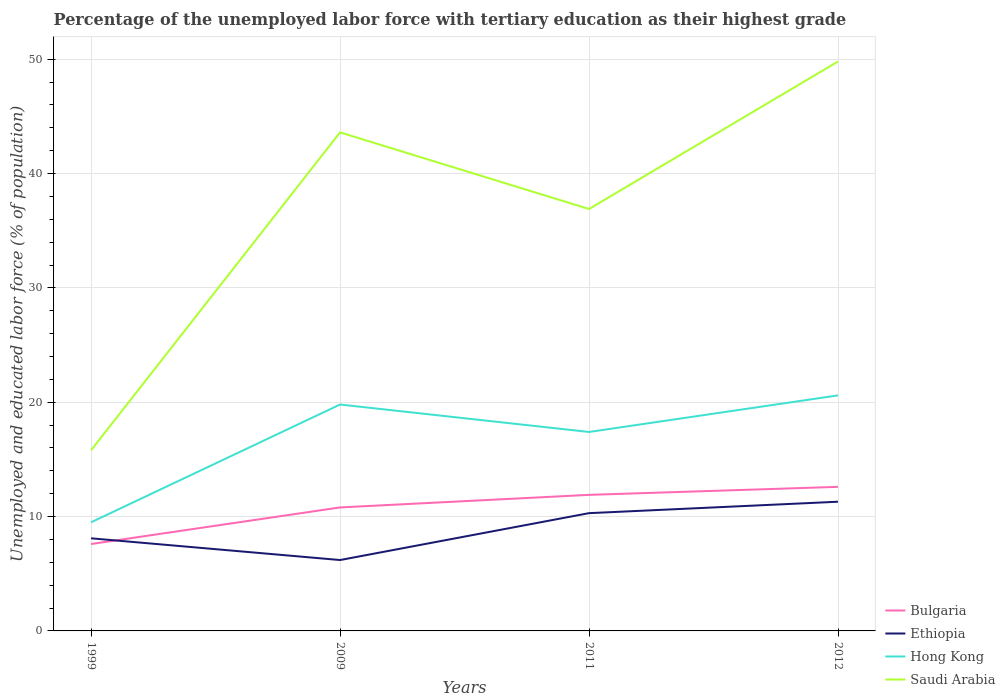How many different coloured lines are there?
Your answer should be very brief. 4. Does the line corresponding to Ethiopia intersect with the line corresponding to Bulgaria?
Offer a very short reply. Yes. Is the number of lines equal to the number of legend labels?
Make the answer very short. Yes. Across all years, what is the maximum percentage of the unemployed labor force with tertiary education in Hong Kong?
Provide a succinct answer. 9.5. What is the total percentage of the unemployed labor force with tertiary education in Ethiopia in the graph?
Your answer should be very brief. -4.1. What is the difference between the highest and the second highest percentage of the unemployed labor force with tertiary education in Hong Kong?
Give a very brief answer. 11.1. Are the values on the major ticks of Y-axis written in scientific E-notation?
Give a very brief answer. No. How many legend labels are there?
Offer a very short reply. 4. What is the title of the graph?
Provide a short and direct response. Percentage of the unemployed labor force with tertiary education as their highest grade. Does "St. Vincent and the Grenadines" appear as one of the legend labels in the graph?
Provide a succinct answer. No. What is the label or title of the Y-axis?
Keep it short and to the point. Unemployed and educated labor force (% of population). What is the Unemployed and educated labor force (% of population) in Bulgaria in 1999?
Offer a terse response. 7.6. What is the Unemployed and educated labor force (% of population) in Ethiopia in 1999?
Your answer should be compact. 8.1. What is the Unemployed and educated labor force (% of population) of Saudi Arabia in 1999?
Your answer should be compact. 15.8. What is the Unemployed and educated labor force (% of population) in Bulgaria in 2009?
Give a very brief answer. 10.8. What is the Unemployed and educated labor force (% of population) of Ethiopia in 2009?
Provide a short and direct response. 6.2. What is the Unemployed and educated labor force (% of population) in Hong Kong in 2009?
Your response must be concise. 19.8. What is the Unemployed and educated labor force (% of population) in Saudi Arabia in 2009?
Keep it short and to the point. 43.6. What is the Unemployed and educated labor force (% of population) of Bulgaria in 2011?
Your response must be concise. 11.9. What is the Unemployed and educated labor force (% of population) in Ethiopia in 2011?
Your response must be concise. 10.3. What is the Unemployed and educated labor force (% of population) of Hong Kong in 2011?
Your answer should be very brief. 17.4. What is the Unemployed and educated labor force (% of population) of Saudi Arabia in 2011?
Keep it short and to the point. 36.9. What is the Unemployed and educated labor force (% of population) of Bulgaria in 2012?
Provide a short and direct response. 12.6. What is the Unemployed and educated labor force (% of population) in Ethiopia in 2012?
Your answer should be compact. 11.3. What is the Unemployed and educated labor force (% of population) of Hong Kong in 2012?
Give a very brief answer. 20.6. What is the Unemployed and educated labor force (% of population) of Saudi Arabia in 2012?
Give a very brief answer. 49.8. Across all years, what is the maximum Unemployed and educated labor force (% of population) in Bulgaria?
Offer a very short reply. 12.6. Across all years, what is the maximum Unemployed and educated labor force (% of population) of Ethiopia?
Provide a short and direct response. 11.3. Across all years, what is the maximum Unemployed and educated labor force (% of population) of Hong Kong?
Your answer should be compact. 20.6. Across all years, what is the maximum Unemployed and educated labor force (% of population) of Saudi Arabia?
Make the answer very short. 49.8. Across all years, what is the minimum Unemployed and educated labor force (% of population) in Bulgaria?
Provide a short and direct response. 7.6. Across all years, what is the minimum Unemployed and educated labor force (% of population) of Ethiopia?
Give a very brief answer. 6.2. Across all years, what is the minimum Unemployed and educated labor force (% of population) of Hong Kong?
Ensure brevity in your answer.  9.5. Across all years, what is the minimum Unemployed and educated labor force (% of population) in Saudi Arabia?
Your response must be concise. 15.8. What is the total Unemployed and educated labor force (% of population) in Bulgaria in the graph?
Your answer should be compact. 42.9. What is the total Unemployed and educated labor force (% of population) in Ethiopia in the graph?
Your response must be concise. 35.9. What is the total Unemployed and educated labor force (% of population) of Hong Kong in the graph?
Your answer should be compact. 67.3. What is the total Unemployed and educated labor force (% of population) in Saudi Arabia in the graph?
Provide a succinct answer. 146.1. What is the difference between the Unemployed and educated labor force (% of population) of Bulgaria in 1999 and that in 2009?
Provide a short and direct response. -3.2. What is the difference between the Unemployed and educated labor force (% of population) in Saudi Arabia in 1999 and that in 2009?
Your answer should be compact. -27.8. What is the difference between the Unemployed and educated labor force (% of population) in Bulgaria in 1999 and that in 2011?
Provide a short and direct response. -4.3. What is the difference between the Unemployed and educated labor force (% of population) in Ethiopia in 1999 and that in 2011?
Offer a terse response. -2.2. What is the difference between the Unemployed and educated labor force (% of population) of Saudi Arabia in 1999 and that in 2011?
Give a very brief answer. -21.1. What is the difference between the Unemployed and educated labor force (% of population) in Ethiopia in 1999 and that in 2012?
Keep it short and to the point. -3.2. What is the difference between the Unemployed and educated labor force (% of population) in Saudi Arabia in 1999 and that in 2012?
Provide a short and direct response. -34. What is the difference between the Unemployed and educated labor force (% of population) in Ethiopia in 2009 and that in 2011?
Your answer should be very brief. -4.1. What is the difference between the Unemployed and educated labor force (% of population) in Hong Kong in 2009 and that in 2011?
Your response must be concise. 2.4. What is the difference between the Unemployed and educated labor force (% of population) in Bulgaria in 2009 and that in 2012?
Provide a short and direct response. -1.8. What is the difference between the Unemployed and educated labor force (% of population) of Bulgaria in 2011 and that in 2012?
Give a very brief answer. -0.7. What is the difference between the Unemployed and educated labor force (% of population) in Bulgaria in 1999 and the Unemployed and educated labor force (% of population) in Ethiopia in 2009?
Offer a terse response. 1.4. What is the difference between the Unemployed and educated labor force (% of population) in Bulgaria in 1999 and the Unemployed and educated labor force (% of population) in Hong Kong in 2009?
Ensure brevity in your answer.  -12.2. What is the difference between the Unemployed and educated labor force (% of population) of Bulgaria in 1999 and the Unemployed and educated labor force (% of population) of Saudi Arabia in 2009?
Ensure brevity in your answer.  -36. What is the difference between the Unemployed and educated labor force (% of population) of Ethiopia in 1999 and the Unemployed and educated labor force (% of population) of Hong Kong in 2009?
Your answer should be very brief. -11.7. What is the difference between the Unemployed and educated labor force (% of population) of Ethiopia in 1999 and the Unemployed and educated labor force (% of population) of Saudi Arabia in 2009?
Provide a succinct answer. -35.5. What is the difference between the Unemployed and educated labor force (% of population) of Hong Kong in 1999 and the Unemployed and educated labor force (% of population) of Saudi Arabia in 2009?
Offer a very short reply. -34.1. What is the difference between the Unemployed and educated labor force (% of population) of Bulgaria in 1999 and the Unemployed and educated labor force (% of population) of Hong Kong in 2011?
Make the answer very short. -9.8. What is the difference between the Unemployed and educated labor force (% of population) in Bulgaria in 1999 and the Unemployed and educated labor force (% of population) in Saudi Arabia in 2011?
Make the answer very short. -29.3. What is the difference between the Unemployed and educated labor force (% of population) in Ethiopia in 1999 and the Unemployed and educated labor force (% of population) in Saudi Arabia in 2011?
Provide a succinct answer. -28.8. What is the difference between the Unemployed and educated labor force (% of population) of Hong Kong in 1999 and the Unemployed and educated labor force (% of population) of Saudi Arabia in 2011?
Offer a terse response. -27.4. What is the difference between the Unemployed and educated labor force (% of population) of Bulgaria in 1999 and the Unemployed and educated labor force (% of population) of Ethiopia in 2012?
Provide a short and direct response. -3.7. What is the difference between the Unemployed and educated labor force (% of population) of Bulgaria in 1999 and the Unemployed and educated labor force (% of population) of Saudi Arabia in 2012?
Your response must be concise. -42.2. What is the difference between the Unemployed and educated labor force (% of population) in Ethiopia in 1999 and the Unemployed and educated labor force (% of population) in Saudi Arabia in 2012?
Provide a short and direct response. -41.7. What is the difference between the Unemployed and educated labor force (% of population) of Hong Kong in 1999 and the Unemployed and educated labor force (% of population) of Saudi Arabia in 2012?
Your answer should be compact. -40.3. What is the difference between the Unemployed and educated labor force (% of population) of Bulgaria in 2009 and the Unemployed and educated labor force (% of population) of Ethiopia in 2011?
Your answer should be very brief. 0.5. What is the difference between the Unemployed and educated labor force (% of population) of Bulgaria in 2009 and the Unemployed and educated labor force (% of population) of Hong Kong in 2011?
Make the answer very short. -6.6. What is the difference between the Unemployed and educated labor force (% of population) of Bulgaria in 2009 and the Unemployed and educated labor force (% of population) of Saudi Arabia in 2011?
Offer a very short reply. -26.1. What is the difference between the Unemployed and educated labor force (% of population) in Ethiopia in 2009 and the Unemployed and educated labor force (% of population) in Hong Kong in 2011?
Keep it short and to the point. -11.2. What is the difference between the Unemployed and educated labor force (% of population) in Ethiopia in 2009 and the Unemployed and educated labor force (% of population) in Saudi Arabia in 2011?
Your answer should be compact. -30.7. What is the difference between the Unemployed and educated labor force (% of population) of Hong Kong in 2009 and the Unemployed and educated labor force (% of population) of Saudi Arabia in 2011?
Provide a succinct answer. -17.1. What is the difference between the Unemployed and educated labor force (% of population) of Bulgaria in 2009 and the Unemployed and educated labor force (% of population) of Ethiopia in 2012?
Your answer should be very brief. -0.5. What is the difference between the Unemployed and educated labor force (% of population) in Bulgaria in 2009 and the Unemployed and educated labor force (% of population) in Hong Kong in 2012?
Your response must be concise. -9.8. What is the difference between the Unemployed and educated labor force (% of population) of Bulgaria in 2009 and the Unemployed and educated labor force (% of population) of Saudi Arabia in 2012?
Offer a very short reply. -39. What is the difference between the Unemployed and educated labor force (% of population) of Ethiopia in 2009 and the Unemployed and educated labor force (% of population) of Hong Kong in 2012?
Your answer should be compact. -14.4. What is the difference between the Unemployed and educated labor force (% of population) in Ethiopia in 2009 and the Unemployed and educated labor force (% of population) in Saudi Arabia in 2012?
Your response must be concise. -43.6. What is the difference between the Unemployed and educated labor force (% of population) of Bulgaria in 2011 and the Unemployed and educated labor force (% of population) of Saudi Arabia in 2012?
Your answer should be very brief. -37.9. What is the difference between the Unemployed and educated labor force (% of population) in Ethiopia in 2011 and the Unemployed and educated labor force (% of population) in Hong Kong in 2012?
Keep it short and to the point. -10.3. What is the difference between the Unemployed and educated labor force (% of population) in Ethiopia in 2011 and the Unemployed and educated labor force (% of population) in Saudi Arabia in 2012?
Your answer should be very brief. -39.5. What is the difference between the Unemployed and educated labor force (% of population) in Hong Kong in 2011 and the Unemployed and educated labor force (% of population) in Saudi Arabia in 2012?
Give a very brief answer. -32.4. What is the average Unemployed and educated labor force (% of population) of Bulgaria per year?
Make the answer very short. 10.72. What is the average Unemployed and educated labor force (% of population) in Ethiopia per year?
Your response must be concise. 8.97. What is the average Unemployed and educated labor force (% of population) of Hong Kong per year?
Offer a very short reply. 16.82. What is the average Unemployed and educated labor force (% of population) in Saudi Arabia per year?
Provide a short and direct response. 36.52. In the year 1999, what is the difference between the Unemployed and educated labor force (% of population) in Bulgaria and Unemployed and educated labor force (% of population) in Ethiopia?
Your answer should be compact. -0.5. In the year 1999, what is the difference between the Unemployed and educated labor force (% of population) in Bulgaria and Unemployed and educated labor force (% of population) in Hong Kong?
Give a very brief answer. -1.9. In the year 1999, what is the difference between the Unemployed and educated labor force (% of population) in Ethiopia and Unemployed and educated labor force (% of population) in Saudi Arabia?
Your answer should be compact. -7.7. In the year 1999, what is the difference between the Unemployed and educated labor force (% of population) in Hong Kong and Unemployed and educated labor force (% of population) in Saudi Arabia?
Offer a terse response. -6.3. In the year 2009, what is the difference between the Unemployed and educated labor force (% of population) in Bulgaria and Unemployed and educated labor force (% of population) in Hong Kong?
Keep it short and to the point. -9. In the year 2009, what is the difference between the Unemployed and educated labor force (% of population) of Bulgaria and Unemployed and educated labor force (% of population) of Saudi Arabia?
Make the answer very short. -32.8. In the year 2009, what is the difference between the Unemployed and educated labor force (% of population) in Ethiopia and Unemployed and educated labor force (% of population) in Hong Kong?
Your answer should be very brief. -13.6. In the year 2009, what is the difference between the Unemployed and educated labor force (% of population) of Ethiopia and Unemployed and educated labor force (% of population) of Saudi Arabia?
Keep it short and to the point. -37.4. In the year 2009, what is the difference between the Unemployed and educated labor force (% of population) in Hong Kong and Unemployed and educated labor force (% of population) in Saudi Arabia?
Offer a very short reply. -23.8. In the year 2011, what is the difference between the Unemployed and educated labor force (% of population) of Bulgaria and Unemployed and educated labor force (% of population) of Hong Kong?
Provide a succinct answer. -5.5. In the year 2011, what is the difference between the Unemployed and educated labor force (% of population) in Bulgaria and Unemployed and educated labor force (% of population) in Saudi Arabia?
Make the answer very short. -25. In the year 2011, what is the difference between the Unemployed and educated labor force (% of population) in Ethiopia and Unemployed and educated labor force (% of population) in Saudi Arabia?
Keep it short and to the point. -26.6. In the year 2011, what is the difference between the Unemployed and educated labor force (% of population) in Hong Kong and Unemployed and educated labor force (% of population) in Saudi Arabia?
Your response must be concise. -19.5. In the year 2012, what is the difference between the Unemployed and educated labor force (% of population) in Bulgaria and Unemployed and educated labor force (% of population) in Hong Kong?
Ensure brevity in your answer.  -8. In the year 2012, what is the difference between the Unemployed and educated labor force (% of population) in Bulgaria and Unemployed and educated labor force (% of population) in Saudi Arabia?
Offer a very short reply. -37.2. In the year 2012, what is the difference between the Unemployed and educated labor force (% of population) of Ethiopia and Unemployed and educated labor force (% of population) of Saudi Arabia?
Your answer should be compact. -38.5. In the year 2012, what is the difference between the Unemployed and educated labor force (% of population) in Hong Kong and Unemployed and educated labor force (% of population) in Saudi Arabia?
Keep it short and to the point. -29.2. What is the ratio of the Unemployed and educated labor force (% of population) of Bulgaria in 1999 to that in 2009?
Your response must be concise. 0.7. What is the ratio of the Unemployed and educated labor force (% of population) in Ethiopia in 1999 to that in 2009?
Make the answer very short. 1.31. What is the ratio of the Unemployed and educated labor force (% of population) of Hong Kong in 1999 to that in 2009?
Offer a terse response. 0.48. What is the ratio of the Unemployed and educated labor force (% of population) of Saudi Arabia in 1999 to that in 2009?
Your response must be concise. 0.36. What is the ratio of the Unemployed and educated labor force (% of population) of Bulgaria in 1999 to that in 2011?
Your response must be concise. 0.64. What is the ratio of the Unemployed and educated labor force (% of population) in Ethiopia in 1999 to that in 2011?
Offer a very short reply. 0.79. What is the ratio of the Unemployed and educated labor force (% of population) in Hong Kong in 1999 to that in 2011?
Offer a terse response. 0.55. What is the ratio of the Unemployed and educated labor force (% of population) of Saudi Arabia in 1999 to that in 2011?
Give a very brief answer. 0.43. What is the ratio of the Unemployed and educated labor force (% of population) of Bulgaria in 1999 to that in 2012?
Your answer should be very brief. 0.6. What is the ratio of the Unemployed and educated labor force (% of population) of Ethiopia in 1999 to that in 2012?
Keep it short and to the point. 0.72. What is the ratio of the Unemployed and educated labor force (% of population) of Hong Kong in 1999 to that in 2012?
Ensure brevity in your answer.  0.46. What is the ratio of the Unemployed and educated labor force (% of population) in Saudi Arabia in 1999 to that in 2012?
Offer a terse response. 0.32. What is the ratio of the Unemployed and educated labor force (% of population) of Bulgaria in 2009 to that in 2011?
Give a very brief answer. 0.91. What is the ratio of the Unemployed and educated labor force (% of population) of Ethiopia in 2009 to that in 2011?
Provide a succinct answer. 0.6. What is the ratio of the Unemployed and educated labor force (% of population) in Hong Kong in 2009 to that in 2011?
Offer a very short reply. 1.14. What is the ratio of the Unemployed and educated labor force (% of population) in Saudi Arabia in 2009 to that in 2011?
Give a very brief answer. 1.18. What is the ratio of the Unemployed and educated labor force (% of population) in Bulgaria in 2009 to that in 2012?
Keep it short and to the point. 0.86. What is the ratio of the Unemployed and educated labor force (% of population) in Ethiopia in 2009 to that in 2012?
Give a very brief answer. 0.55. What is the ratio of the Unemployed and educated labor force (% of population) of Hong Kong in 2009 to that in 2012?
Your answer should be very brief. 0.96. What is the ratio of the Unemployed and educated labor force (% of population) of Saudi Arabia in 2009 to that in 2012?
Your response must be concise. 0.88. What is the ratio of the Unemployed and educated labor force (% of population) in Ethiopia in 2011 to that in 2012?
Give a very brief answer. 0.91. What is the ratio of the Unemployed and educated labor force (% of population) in Hong Kong in 2011 to that in 2012?
Provide a short and direct response. 0.84. What is the ratio of the Unemployed and educated labor force (% of population) of Saudi Arabia in 2011 to that in 2012?
Your answer should be compact. 0.74. What is the difference between the highest and the second highest Unemployed and educated labor force (% of population) of Ethiopia?
Your answer should be compact. 1. What is the difference between the highest and the second highest Unemployed and educated labor force (% of population) in Hong Kong?
Keep it short and to the point. 0.8. What is the difference between the highest and the lowest Unemployed and educated labor force (% of population) of Bulgaria?
Make the answer very short. 5. What is the difference between the highest and the lowest Unemployed and educated labor force (% of population) in Saudi Arabia?
Your answer should be compact. 34. 